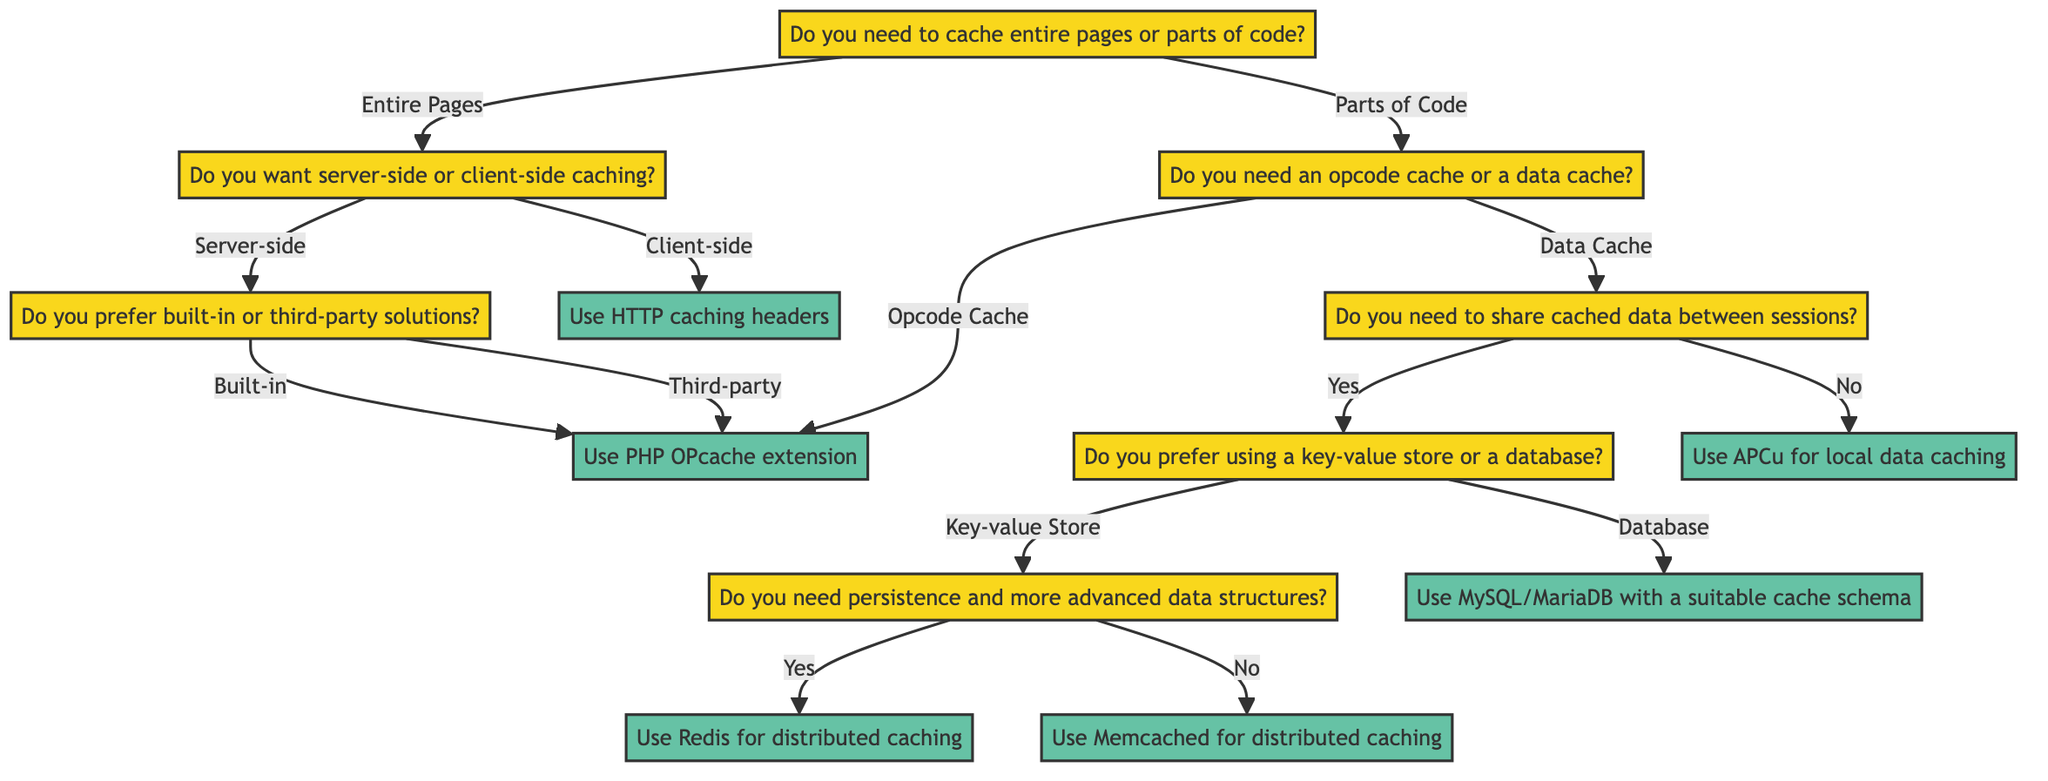What is the starting question in the diagram? The starting question is the first node in the diagram, which asks if there is a need to cache entire pages or parts of code.
Answer: Do you need to cache entire pages or parts of code? How many options are available after the first question? After the first question, there are two options available: "Entire Pages" and "Parts of Code."
Answer: Two What do you get if you choose "Client-side" after the first question? If "Client-side" is chosen after the first question, the decision is to use HTTP caching headers like 'Cache-Control' and 'Expires.'
Answer: Use HTTP caching headers like 'Cache-Control' and 'Expires' What happens if you need to share cached data between sessions and choose the "Yes" option? Choosing "Yes" leads to another question asking if a key-value store or a database is preferred. This continues to branch out towards a final decision.
Answer: Do you prefer using a key-value store or a database? What is the final decision for using a key-value store with persistence? If the user requires persistence and chooses "Yes" for key-value store, the final decision is to use Redis for distributed caching.
Answer: Use Redis for distributed caching What is the decision for local caching? The decision for local caching is reached through the "No" option when asked about sharing cached data between sessions, which leads to using APCu for local data caching.
Answer: Use APCu for local data caching Which caching method should be used for built-in server-side caching solutions? For built-in server-side caching options, the decision is to use the PHP OPcache extension.
Answer: Use PHP OPcache extension What is the relationship between "Parts of Code" and "Opcode Cache"? If "Parts of Code" is selected, the next question asks if an opcode cache or data cache is needed, leading down to the decision for opcode caching.
Answer: Goes to "Opcode Cache" What happens if the database option is selected for a data cache share? Selecting the database option leads to a final decision stating to use MySQL/MariaDB with a suitable cache schema.
Answer: Use MySQL/MariaDB with a suitable cache schema 